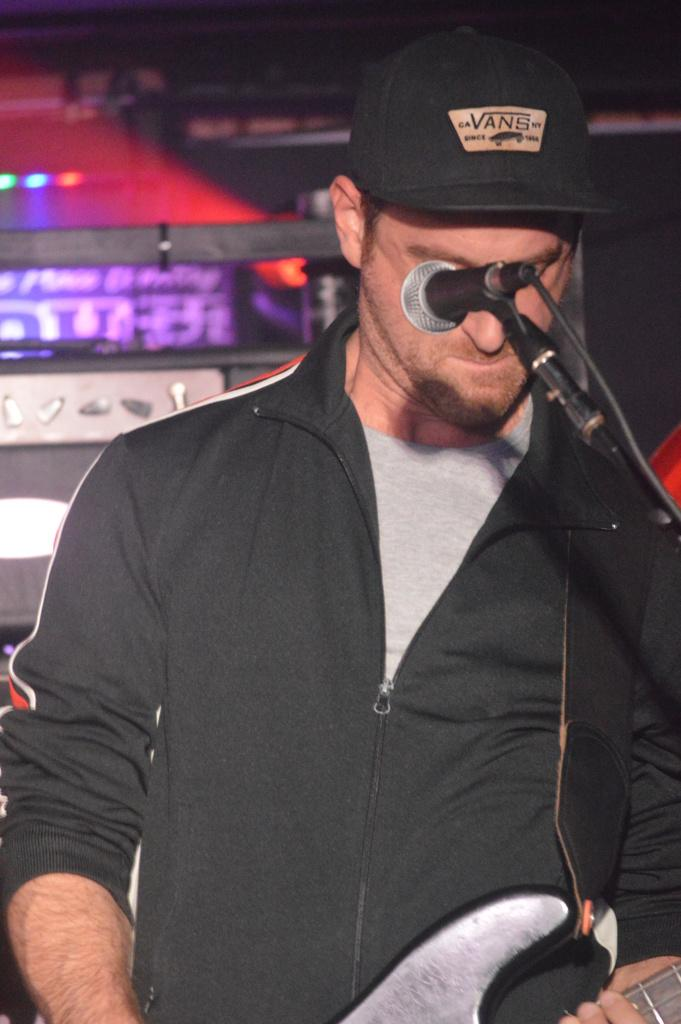What is the man in the image doing? The man is playing a guitar in the image. What object is present in the image that is commonly used for amplifying sound? There is a microphone in the image. What type of dress is the queen wearing in the image? There is no queen or dress present in the image; it features a man playing a guitar and a microphone. 